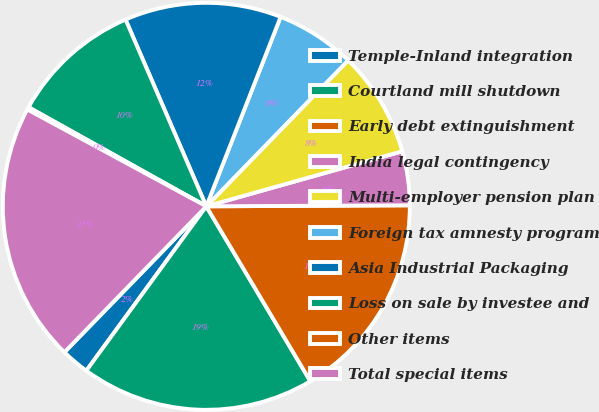<chart> <loc_0><loc_0><loc_500><loc_500><pie_chart><fcel>Temple-Inland integration<fcel>Courtland mill shutdown<fcel>Early debt extinguishment<fcel>India legal contingency<fcel>Multi-employer pension plan<fcel>Foreign tax amnesty program<fcel>Asia Industrial Packaging<fcel>Loss on sale by investee and<fcel>Other items<fcel>Total special items<nl><fcel>2.24%<fcel>18.58%<fcel>16.54%<fcel>4.28%<fcel>8.37%<fcel>6.32%<fcel>12.45%<fcel>10.41%<fcel>0.2%<fcel>20.62%<nl></chart> 